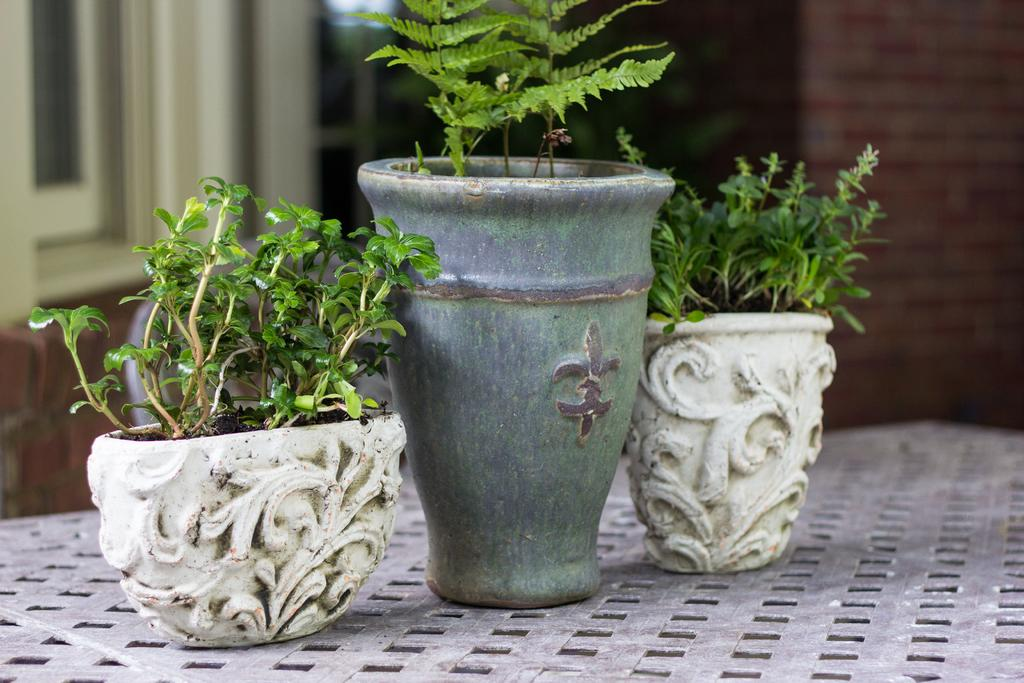How many flower pots are visible in the image? There are three flower pots in the image. Where are the flower pots located? The flower pots are on a table. What can be seen in the background of the image? There is a building in the background of the image. What type of crime is being committed in the image? There is no crime present in the image; it features flower pots on a table with a building in the background. What flavor of cracker is being eaten by the person in the image? There is no person or cracker present in the image. 